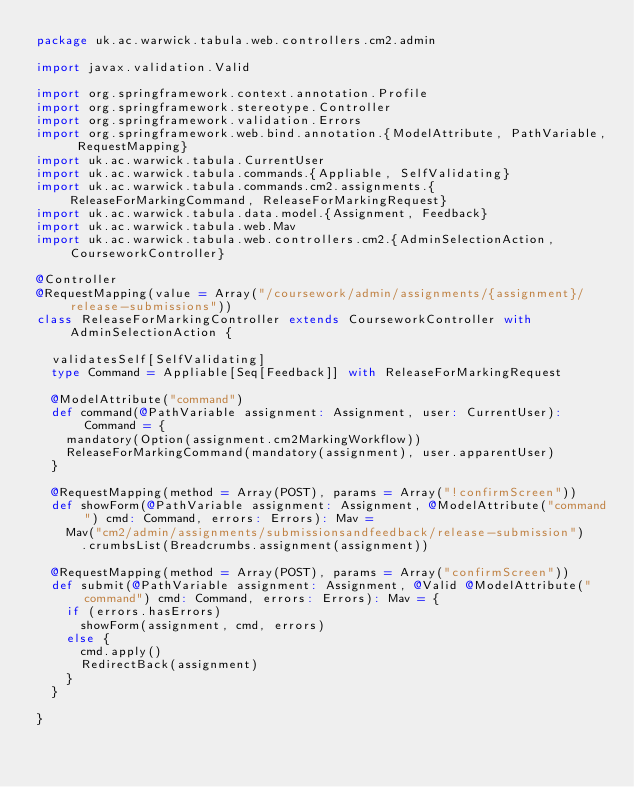Convert code to text. <code><loc_0><loc_0><loc_500><loc_500><_Scala_>package uk.ac.warwick.tabula.web.controllers.cm2.admin

import javax.validation.Valid

import org.springframework.context.annotation.Profile
import org.springframework.stereotype.Controller
import org.springframework.validation.Errors
import org.springframework.web.bind.annotation.{ModelAttribute, PathVariable, RequestMapping}
import uk.ac.warwick.tabula.CurrentUser
import uk.ac.warwick.tabula.commands.{Appliable, SelfValidating}
import uk.ac.warwick.tabula.commands.cm2.assignments.{ReleaseForMarkingCommand, ReleaseForMarkingRequest}
import uk.ac.warwick.tabula.data.model.{Assignment, Feedback}
import uk.ac.warwick.tabula.web.Mav
import uk.ac.warwick.tabula.web.controllers.cm2.{AdminSelectionAction, CourseworkController}

@Controller
@RequestMapping(value = Array("/coursework/admin/assignments/{assignment}/release-submissions"))
class ReleaseForMarkingController extends CourseworkController with AdminSelectionAction {

  validatesSelf[SelfValidating]
  type Command = Appliable[Seq[Feedback]] with ReleaseForMarkingRequest

  @ModelAttribute("command")
  def command(@PathVariable assignment: Assignment, user: CurrentUser): Command = {
    mandatory(Option(assignment.cm2MarkingWorkflow))
    ReleaseForMarkingCommand(mandatory(assignment), user.apparentUser)
  }

  @RequestMapping(method = Array(POST), params = Array("!confirmScreen"))
  def showForm(@PathVariable assignment: Assignment, @ModelAttribute("command") cmd: Command, errors: Errors): Mav =
    Mav("cm2/admin/assignments/submissionsandfeedback/release-submission")
      .crumbsList(Breadcrumbs.assignment(assignment))

  @RequestMapping(method = Array(POST), params = Array("confirmScreen"))
  def submit(@PathVariable assignment: Assignment, @Valid @ModelAttribute("command") cmd: Command, errors: Errors): Mav = {
    if (errors.hasErrors)
      showForm(assignment, cmd, errors)
    else {
      cmd.apply()
      RedirectBack(assignment)
    }
  }

}
</code> 